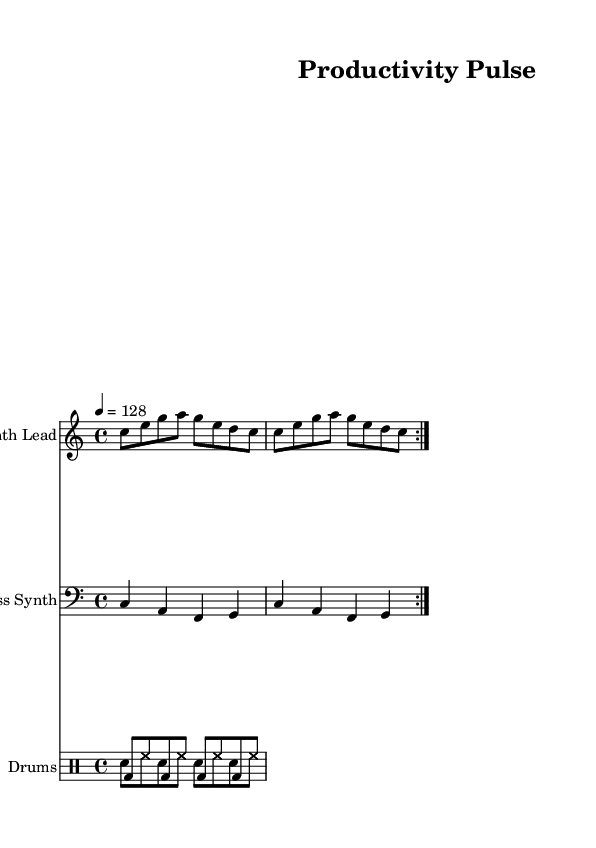What is the key signature of this music? The key signature is found at the beginning of the score and shows no sharps or flats, indicating it is in C major.
Answer: C major What is the time signature of this music? The time signature is represented by the two numbers at the beginning of the score, indicating there are four beats in a measure with a quarter note getting one beat.
Answer: 4/4 What is the tempo marking in this piece? The tempo is indicated in beats per minute by the number at the beginning, which shows that the piece should be played at 128 beats per minute.
Answer: 128 How many measures are repeated in the synth lead? The repeated section is indicated by the volta markings, which specify that the section will play two times for a total of two measures.
Answer: 2 measures What rhythmic pattern is primarily used by the bass synth? By examining the rhythmic structure of the bass line, it can be noted that each note receives a quarter note duration, indicating a stable rhythmic pulse typical in dance music.
Answer: Quarter notes What is the role of the drum pattern in this score? The drum pattern consists of a combination of bass drum and snare hits, which provides a driving rhythm essential in dance music, maintaining a steady beat throughout the piece.
Answer: Driving rhythm What type of synth line is featured in this piece? The synth line is characterized by its use of eighth notes, providing a melodic and upbeat quality appropriate for motivating and energizing the listener, typical in electronic dance music.
Answer: Synth lead 